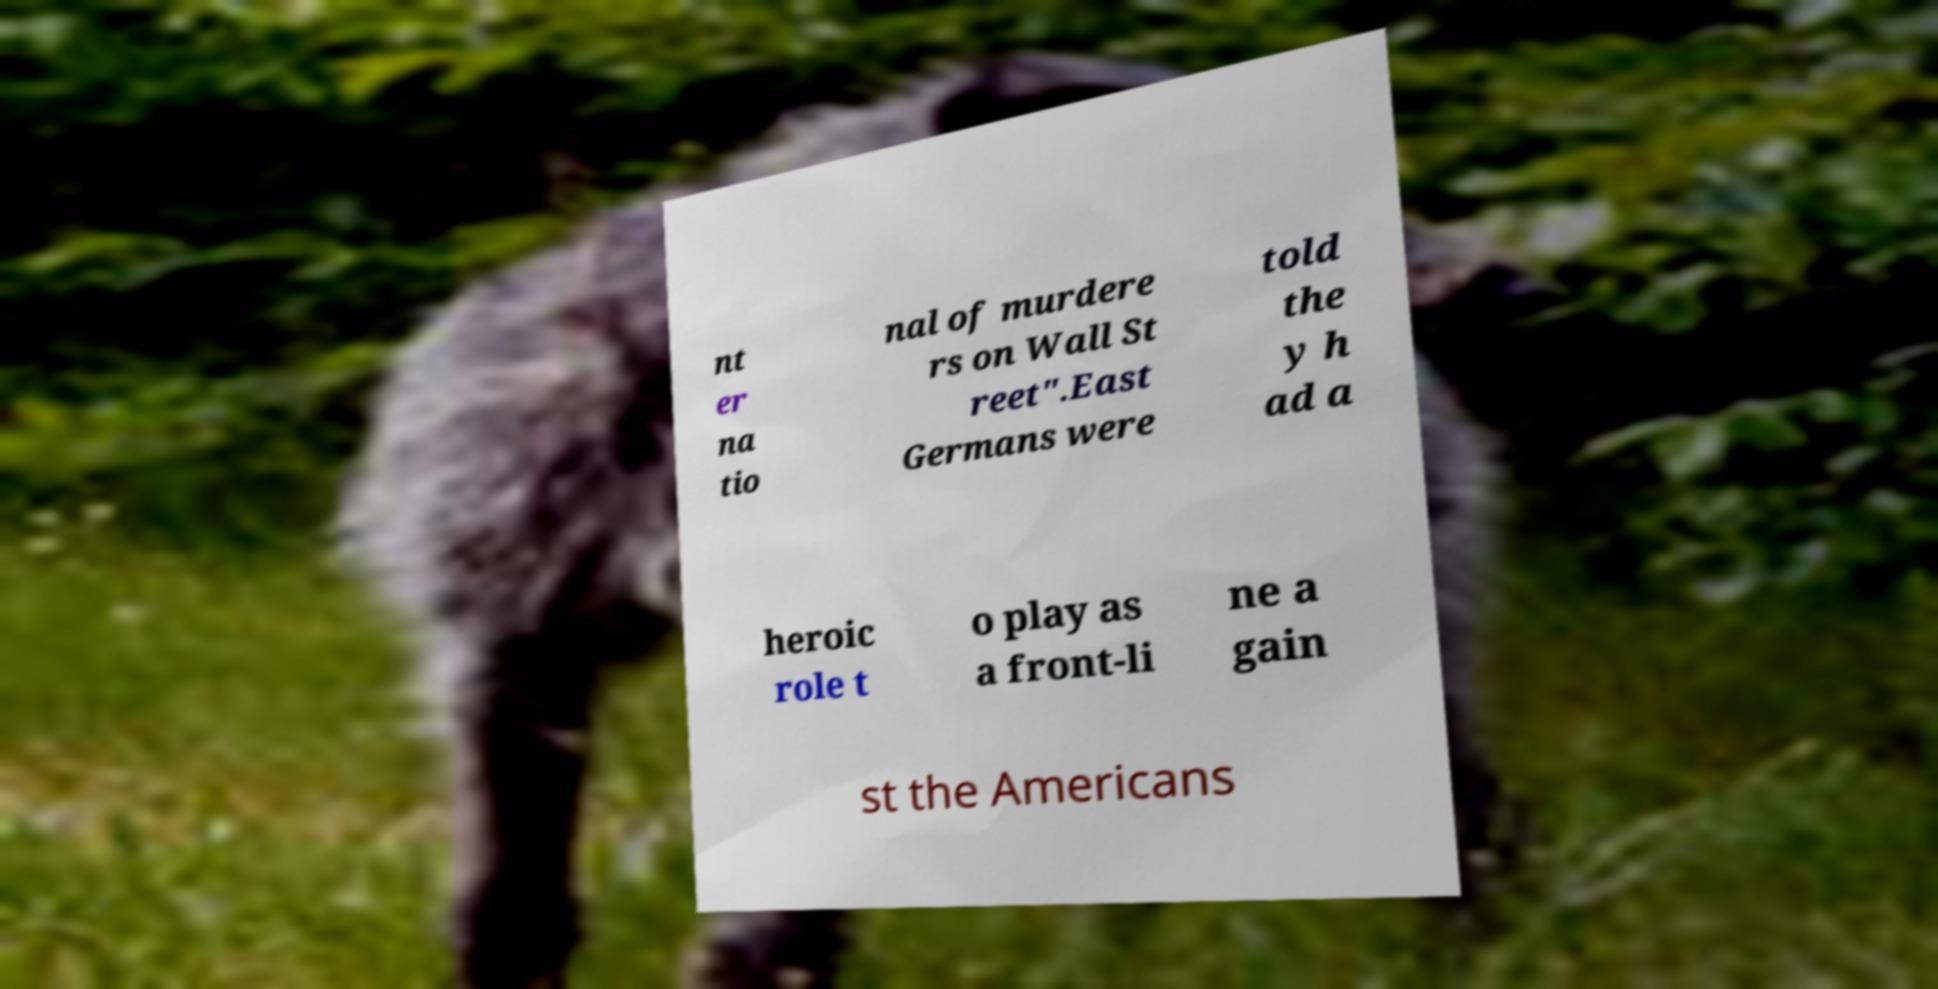Can you accurately transcribe the text from the provided image for me? nt er na tio nal of murdere rs on Wall St reet".East Germans were told the y h ad a heroic role t o play as a front-li ne a gain st the Americans 